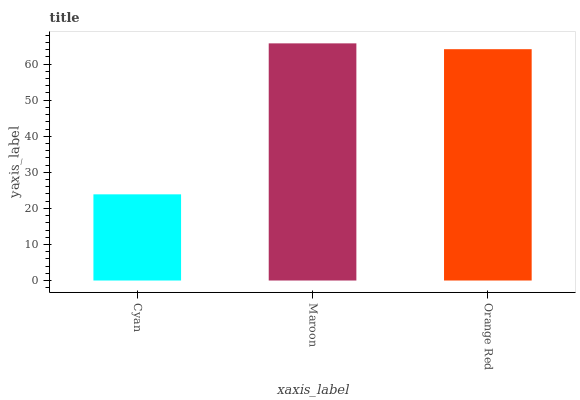Is Orange Red the minimum?
Answer yes or no. No. Is Orange Red the maximum?
Answer yes or no. No. Is Maroon greater than Orange Red?
Answer yes or no. Yes. Is Orange Red less than Maroon?
Answer yes or no. Yes. Is Orange Red greater than Maroon?
Answer yes or no. No. Is Maroon less than Orange Red?
Answer yes or no. No. Is Orange Red the high median?
Answer yes or no. Yes. Is Orange Red the low median?
Answer yes or no. Yes. Is Cyan the high median?
Answer yes or no. No. Is Maroon the low median?
Answer yes or no. No. 